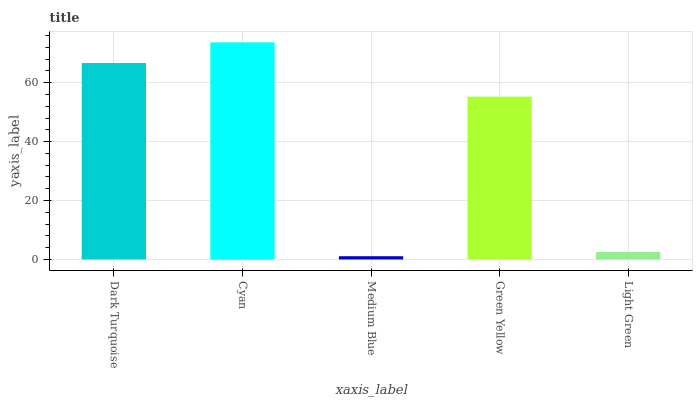Is Medium Blue the minimum?
Answer yes or no. Yes. Is Cyan the maximum?
Answer yes or no. Yes. Is Cyan the minimum?
Answer yes or no. No. Is Medium Blue the maximum?
Answer yes or no. No. Is Cyan greater than Medium Blue?
Answer yes or no. Yes. Is Medium Blue less than Cyan?
Answer yes or no. Yes. Is Medium Blue greater than Cyan?
Answer yes or no. No. Is Cyan less than Medium Blue?
Answer yes or no. No. Is Green Yellow the high median?
Answer yes or no. Yes. Is Green Yellow the low median?
Answer yes or no. Yes. Is Cyan the high median?
Answer yes or no. No. Is Medium Blue the low median?
Answer yes or no. No. 